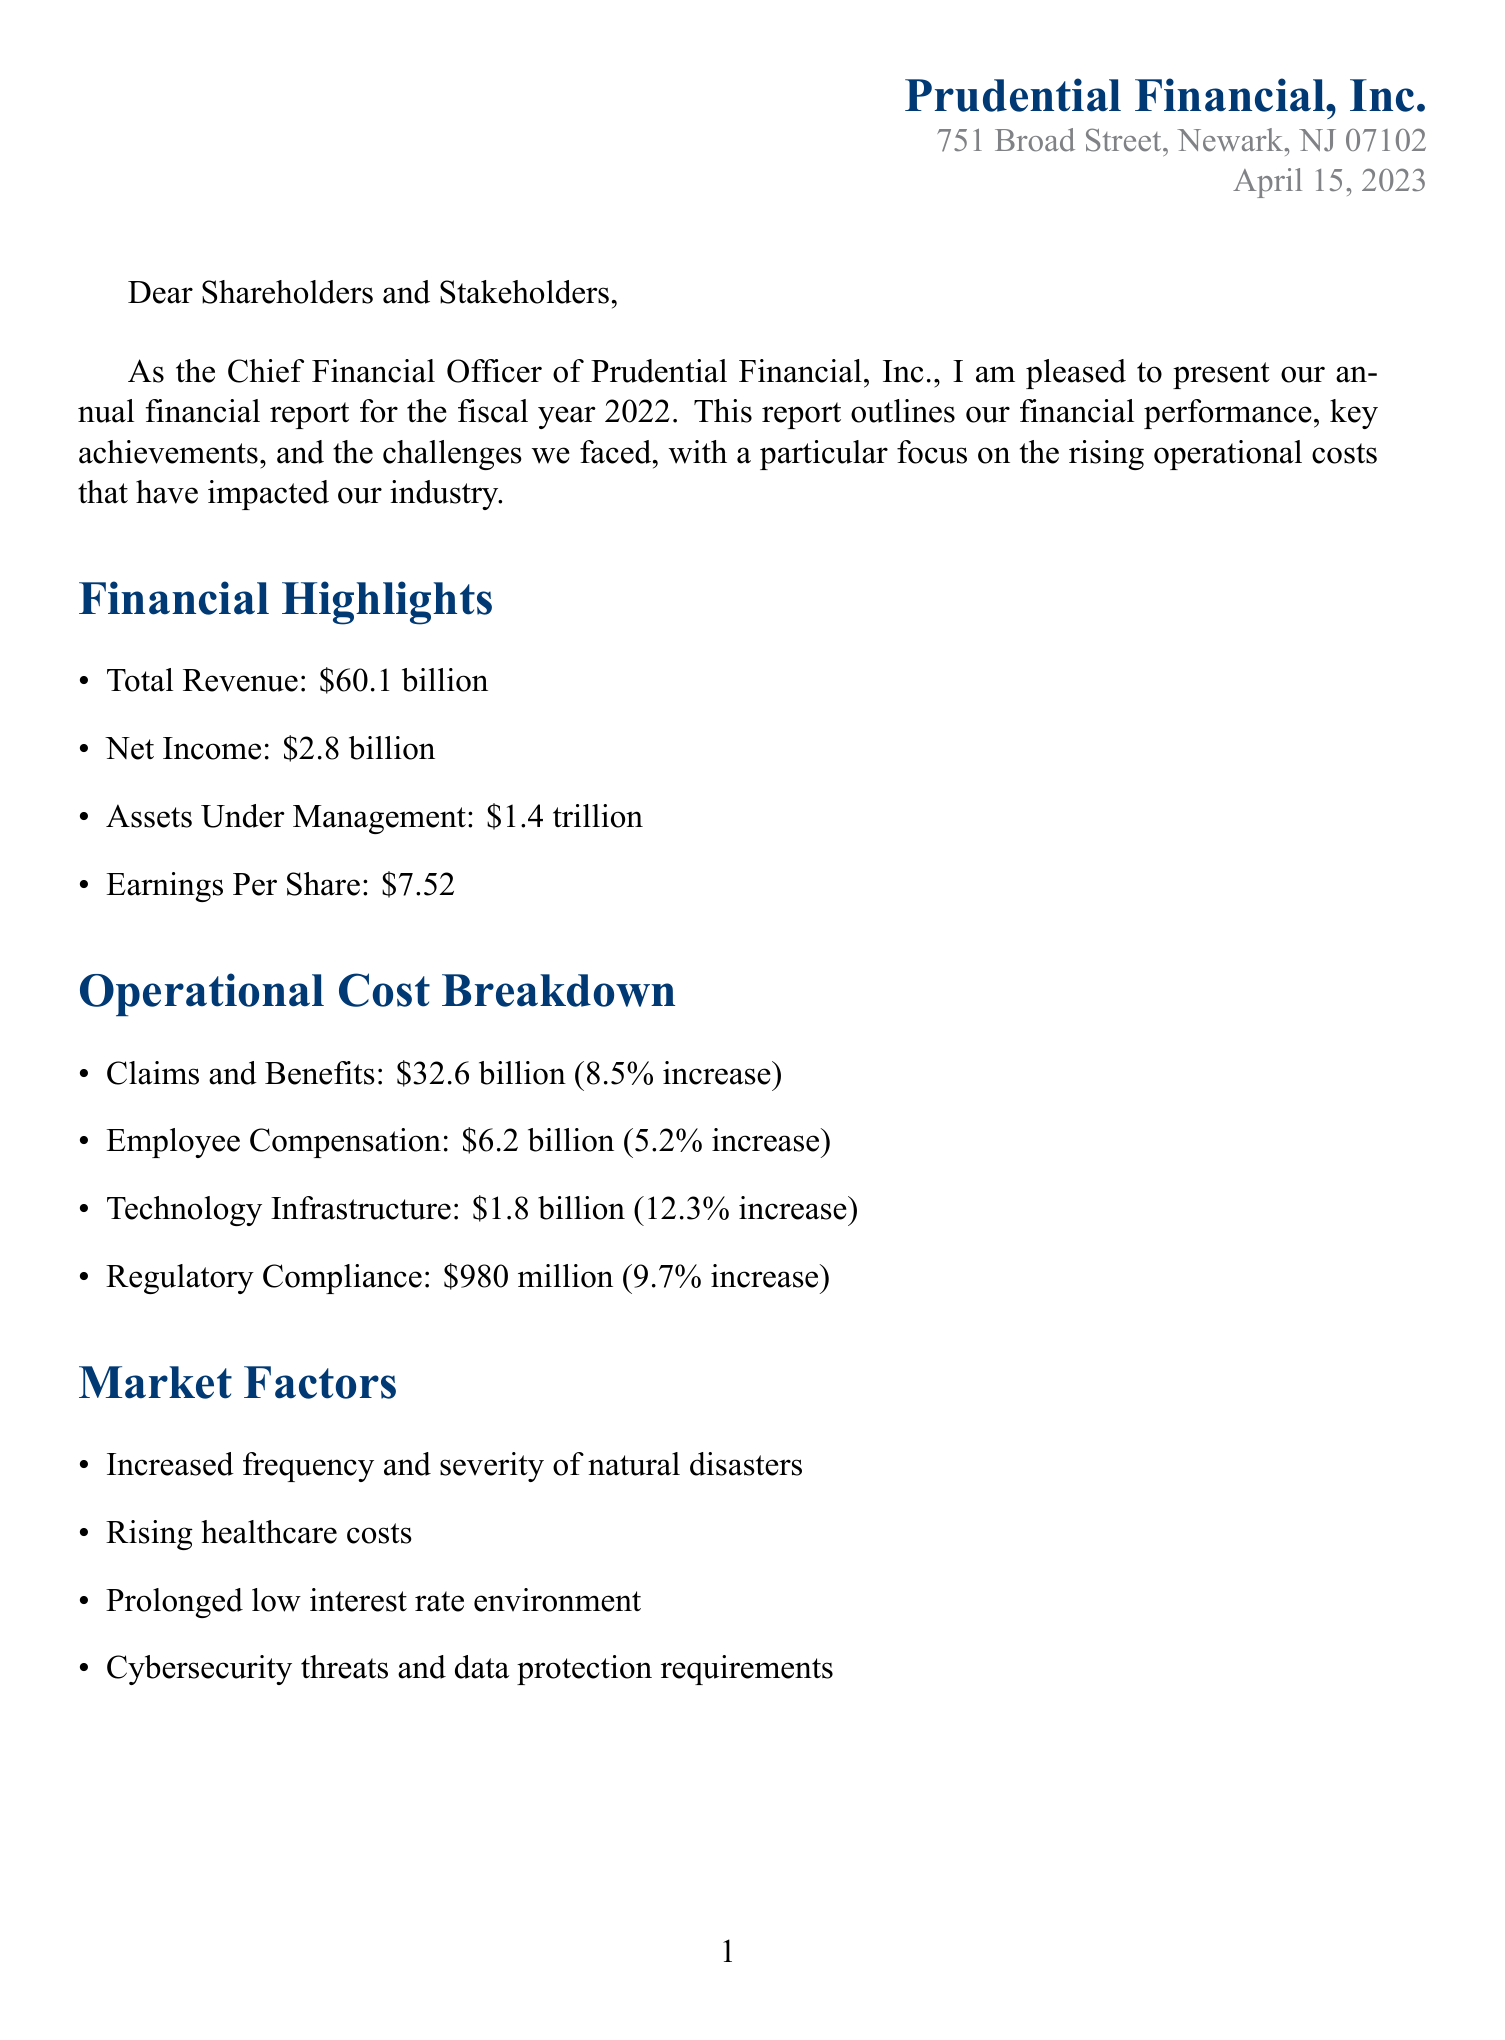what is the company's net income? The net income is a key financial metric that shows the company's profitability, which is stated in the document as $2.8 billion.
Answer: $2.8 billion what is the total operational cost for claims and benefits? The document specifies the amount allocated for claims and benefits, which is $32.6 billion.
Answer: $32.6 billion how much is being invested in digital transformation? The document mentions an investment amount for digital transformation, which is $500 million.
Answer: $500 million what percentage increase is noted for technology infrastructure? The percentage increase for technology infrastructure is explicitly stated in the document as 12.3%.
Answer: 12.3% what market factor is related to climate events? The document lists "Increased frequency and severity of natural disasters" as a market factor affecting operations.
Answer: Increased frequency and severity of natural disasters what strategic initiative aims to enhance customer experience? The document indicates plans for a new mobile app aimed at improving customer experience.
Answer: Launching a new mobile app for policy management and claims submission which regulatory compliance cost percentage increase is mentioned? The document reports a percentage increase for regulatory compliance costs, which is noted as 9.7%.
Answer: 9.7% 